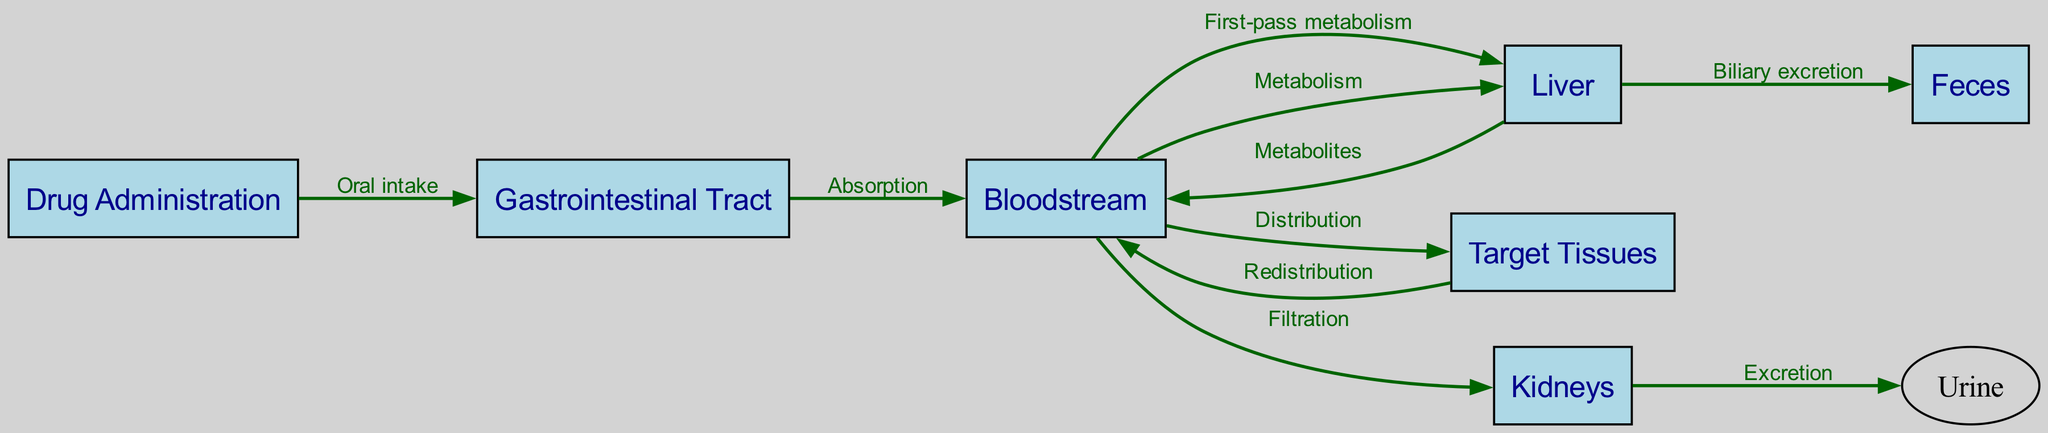What is the first node in the pharmacokinetic pathway? The first node in the pathway is where the drug enters the system, which is indicated as "Drug Administration."
Answer: Drug Administration How many nodes are in the diagram? The diagram lists a total of six distinct nodes: Drug Administration, Gastrointestinal Tract, Bloodstream, Liver, Target Tissues, Kidneys, and Feces.
Answer: Six What is the relationship between the 'Gastrointestinal Tract' and the 'Bloodstream'? The directed edge from the 'Gastrointestinal Tract' to 'Bloodstream' is labelled "Absorption," indicating that this is the process by which the drug enters the bloodstream.
Answer: Absorption What process occurs from 'Bloodstream' to 'Liver'? The flow from the 'Bloodstream' to 'Liver' is labelled "First-pass metabolism," which is a critical step of drug processing before it reaches systemic circulation.
Answer: First-pass metabolism What is the final destination for drug metabolites from the 'Liver'? The drug metabolites from the 'Liver' can exit the body through "Feces," as indicated by the directed edge leading to this endpoint.
Answer: Feces What happens to the drug after it is distributed to 'Target Tissues'? After distribution to 'Target Tissues,' the drug can return to the 'Bloodstream' through a process termed "Redistribution," indicating that it can circulate back to the blood.
Answer: Redistribution What is the pathway for drug excretion through 'Kidneys'? The pathway involves filtration of the drug from the 'Bloodstream' to 'Kidneys' followed by "Excretion" of the drug into "Urine," indicating a two-step process.
Answer: Excretion Which node is connected to both the 'Bloodstream' and 'Feces'? The 'Liver' node is connected to the 'Bloodstream' (through Metabolism) and has an outgoing edge leading to 'Feces' for biliary excretion, indicating its involvement in both processes.
Answer: Liver 